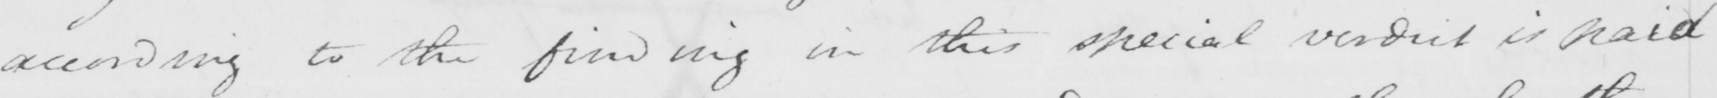Can you tell me what this handwritten text says? according to the finding in this special verdict is paid 